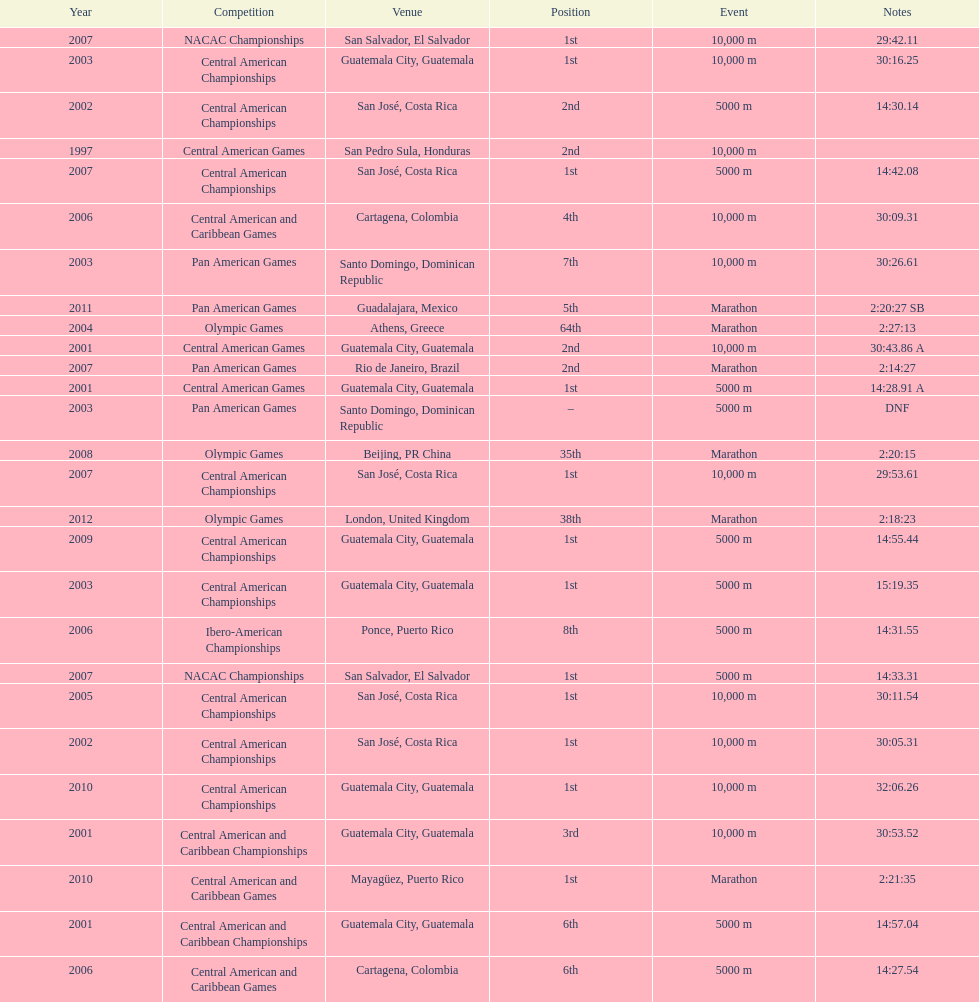What was the last competition in which a position of "2nd" was achieved? Pan American Games. 